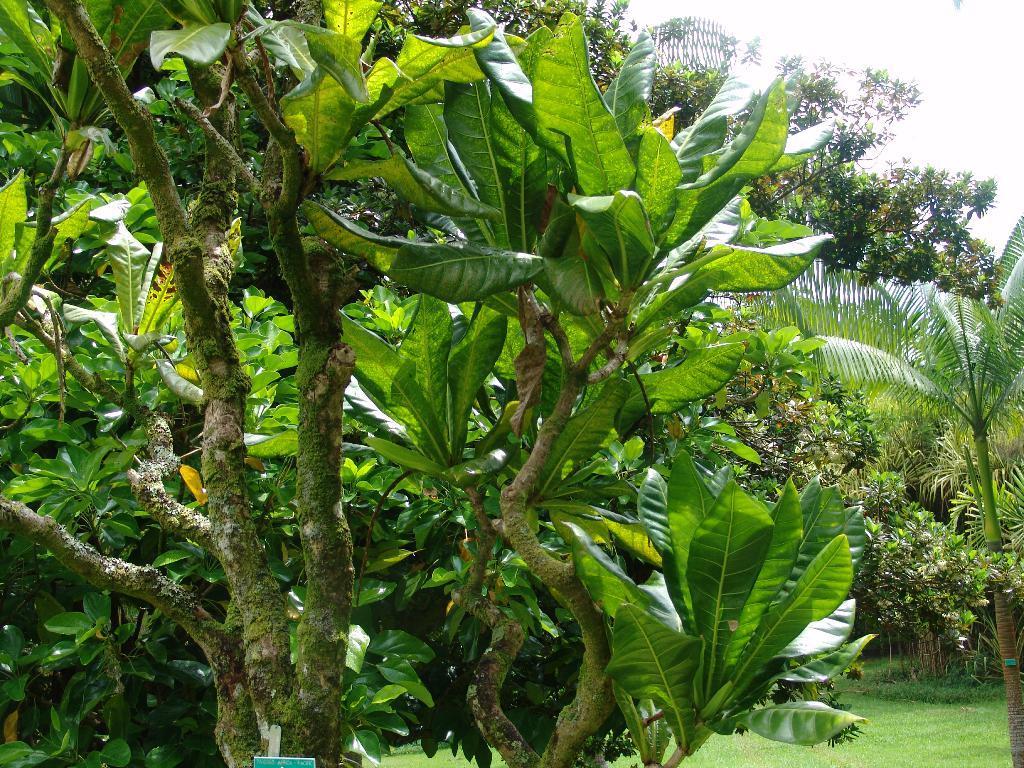How would you summarize this image in a sentence or two? In this image, we can see trees and at the bottom, there is ground. At the top, there is sky. 